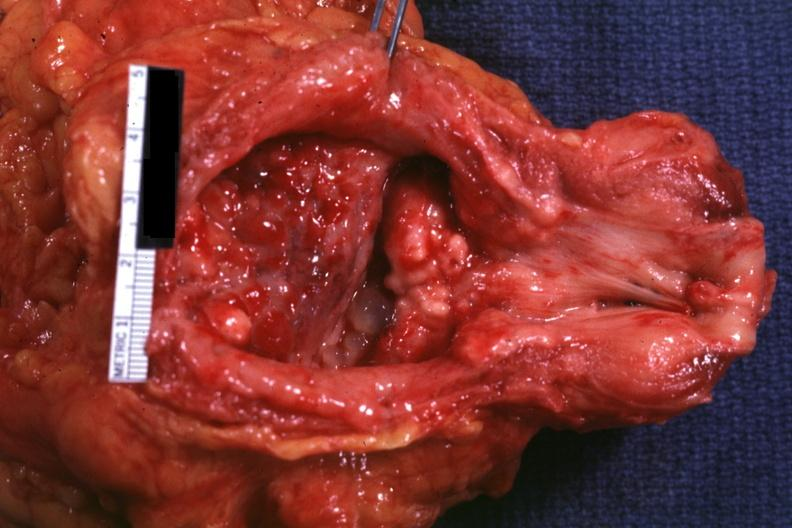what does this image show?
Answer the question using a single word or phrase. Opened bladder and urethra with granular tumor masses visible in floor of bladder quite good 